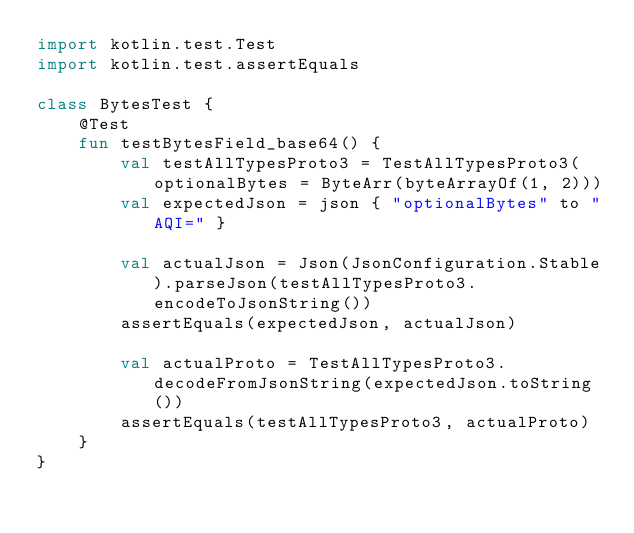<code> <loc_0><loc_0><loc_500><loc_500><_Kotlin_>import kotlin.test.Test
import kotlin.test.assertEquals

class BytesTest {
    @Test
    fun testBytesField_base64() {
        val testAllTypesProto3 = TestAllTypesProto3(optionalBytes = ByteArr(byteArrayOf(1, 2)))
        val expectedJson = json { "optionalBytes" to "AQI=" }

        val actualJson = Json(JsonConfiguration.Stable).parseJson(testAllTypesProto3.encodeToJsonString())
        assertEquals(expectedJson, actualJson)

        val actualProto = TestAllTypesProto3.decodeFromJsonString(expectedJson.toString())
        assertEquals(testAllTypesProto3, actualProto)
    }
}</code> 